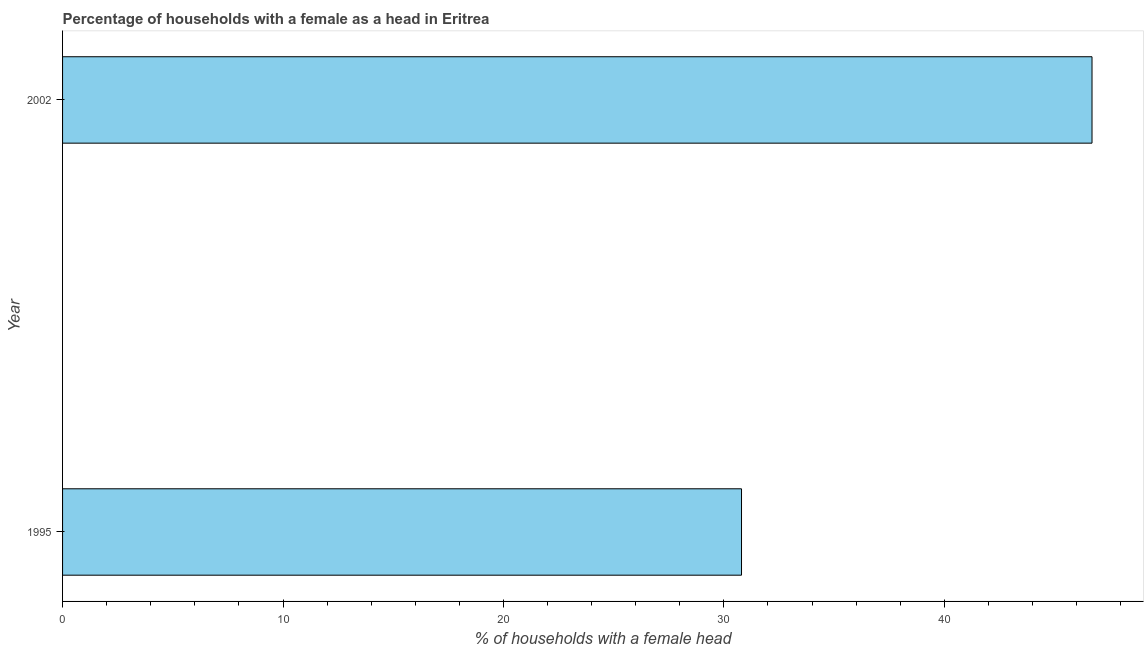What is the title of the graph?
Your answer should be compact. Percentage of households with a female as a head in Eritrea. What is the label or title of the X-axis?
Provide a short and direct response. % of households with a female head. What is the number of female supervised households in 1995?
Provide a short and direct response. 30.8. Across all years, what is the maximum number of female supervised households?
Make the answer very short. 46.7. Across all years, what is the minimum number of female supervised households?
Provide a succinct answer. 30.8. In which year was the number of female supervised households maximum?
Offer a very short reply. 2002. In which year was the number of female supervised households minimum?
Your response must be concise. 1995. What is the sum of the number of female supervised households?
Your answer should be compact. 77.5. What is the difference between the number of female supervised households in 1995 and 2002?
Provide a succinct answer. -15.9. What is the average number of female supervised households per year?
Keep it short and to the point. 38.75. What is the median number of female supervised households?
Your answer should be very brief. 38.75. In how many years, is the number of female supervised households greater than 28 %?
Provide a short and direct response. 2. What is the ratio of the number of female supervised households in 1995 to that in 2002?
Give a very brief answer. 0.66. Is the number of female supervised households in 1995 less than that in 2002?
Offer a terse response. Yes. In how many years, is the number of female supervised households greater than the average number of female supervised households taken over all years?
Offer a terse response. 1. Are all the bars in the graph horizontal?
Provide a short and direct response. Yes. What is the difference between two consecutive major ticks on the X-axis?
Give a very brief answer. 10. Are the values on the major ticks of X-axis written in scientific E-notation?
Provide a succinct answer. No. What is the % of households with a female head in 1995?
Give a very brief answer. 30.8. What is the % of households with a female head in 2002?
Your answer should be very brief. 46.7. What is the difference between the % of households with a female head in 1995 and 2002?
Give a very brief answer. -15.9. What is the ratio of the % of households with a female head in 1995 to that in 2002?
Provide a succinct answer. 0.66. 